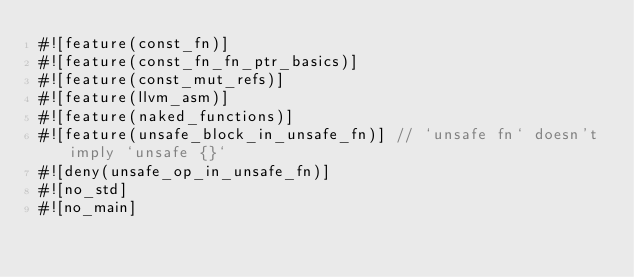Convert code to text. <code><loc_0><loc_0><loc_500><loc_500><_Rust_>#![feature(const_fn)]
#![feature(const_fn_fn_ptr_basics)]
#![feature(const_mut_refs)]
#![feature(llvm_asm)]
#![feature(naked_functions)]
#![feature(unsafe_block_in_unsafe_fn)] // `unsafe fn` doesn't imply `unsafe {}`
#![deny(unsafe_op_in_unsafe_fn)]
#![no_std]
#![no_main]</code> 